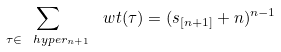Convert formula to latex. <formula><loc_0><loc_0><loc_500><loc_500>\sum _ { \tau \in \ h y p e r _ { n + 1 } } \ w t ( \tau ) = ( s _ { [ n + 1 ] } + n ) ^ { n - 1 }</formula> 